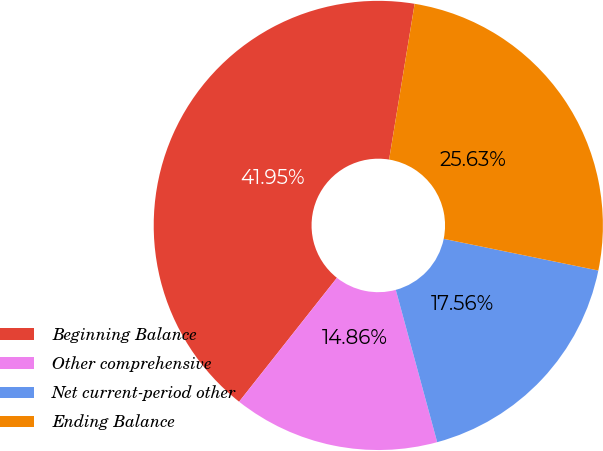Convert chart to OTSL. <chart><loc_0><loc_0><loc_500><loc_500><pie_chart><fcel>Beginning Balance<fcel>Other comprehensive<fcel>Net current-period other<fcel>Ending Balance<nl><fcel>41.95%<fcel>14.86%<fcel>17.56%<fcel>25.63%<nl></chart> 